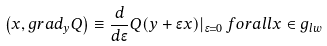Convert formula to latex. <formula><loc_0><loc_0><loc_500><loc_500>\left ( x , g r a d _ { y } Q \right ) \equiv \frac { d } { d \epsilon } Q ( y + \epsilon x ) | _ { \epsilon = 0 } \, f o r a l l x \in g _ { l w }</formula> 